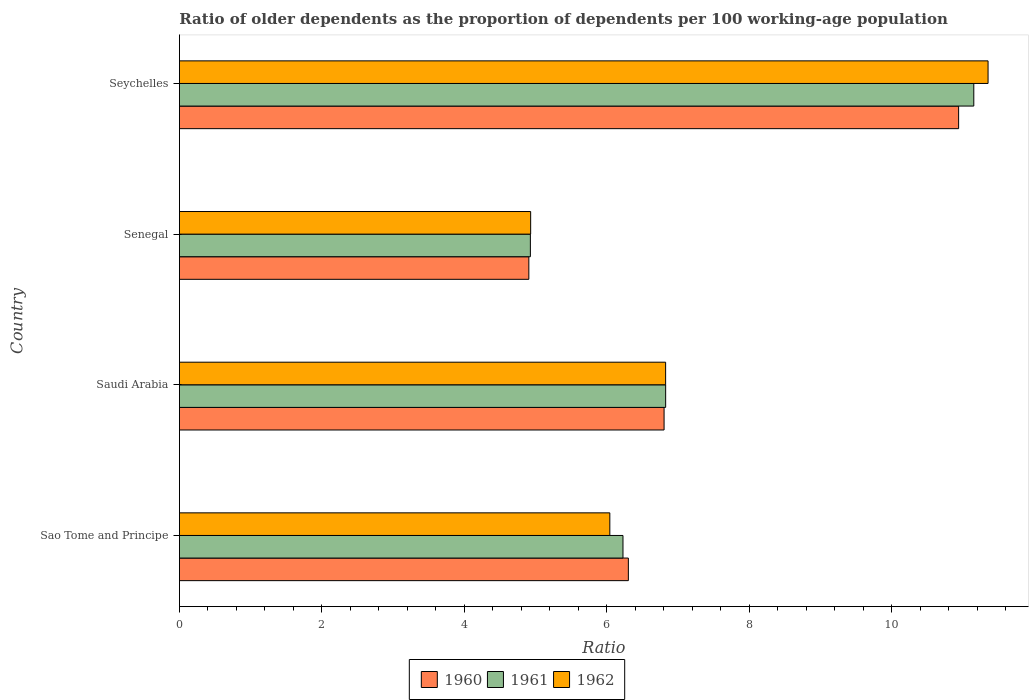How many different coloured bars are there?
Offer a terse response. 3. How many bars are there on the 2nd tick from the top?
Give a very brief answer. 3. What is the label of the 3rd group of bars from the top?
Your answer should be compact. Saudi Arabia. What is the age dependency ratio(old) in 1960 in Saudi Arabia?
Make the answer very short. 6.8. Across all countries, what is the maximum age dependency ratio(old) in 1962?
Keep it short and to the point. 11.35. Across all countries, what is the minimum age dependency ratio(old) in 1962?
Offer a terse response. 4.93. In which country was the age dependency ratio(old) in 1961 maximum?
Your answer should be very brief. Seychelles. In which country was the age dependency ratio(old) in 1962 minimum?
Offer a terse response. Senegal. What is the total age dependency ratio(old) in 1961 in the graph?
Give a very brief answer. 29.13. What is the difference between the age dependency ratio(old) in 1961 in Sao Tome and Principe and that in Saudi Arabia?
Provide a short and direct response. -0.6. What is the difference between the age dependency ratio(old) in 1962 in Saudi Arabia and the age dependency ratio(old) in 1960 in Senegal?
Ensure brevity in your answer.  1.92. What is the average age dependency ratio(old) in 1962 per country?
Your answer should be compact. 7.29. What is the difference between the age dependency ratio(old) in 1960 and age dependency ratio(old) in 1961 in Saudi Arabia?
Ensure brevity in your answer.  -0.02. What is the ratio of the age dependency ratio(old) in 1962 in Sao Tome and Principe to that in Saudi Arabia?
Your response must be concise. 0.89. Is the age dependency ratio(old) in 1960 in Saudi Arabia less than that in Seychelles?
Ensure brevity in your answer.  Yes. Is the difference between the age dependency ratio(old) in 1960 in Sao Tome and Principe and Seychelles greater than the difference between the age dependency ratio(old) in 1961 in Sao Tome and Principe and Seychelles?
Keep it short and to the point. Yes. What is the difference between the highest and the second highest age dependency ratio(old) in 1960?
Your response must be concise. 4.13. What is the difference between the highest and the lowest age dependency ratio(old) in 1962?
Your response must be concise. 6.42. Is the sum of the age dependency ratio(old) in 1960 in Sao Tome and Principe and Saudi Arabia greater than the maximum age dependency ratio(old) in 1961 across all countries?
Ensure brevity in your answer.  Yes. Is it the case that in every country, the sum of the age dependency ratio(old) in 1960 and age dependency ratio(old) in 1962 is greater than the age dependency ratio(old) in 1961?
Provide a succinct answer. Yes. Are all the bars in the graph horizontal?
Your response must be concise. Yes. How many countries are there in the graph?
Your response must be concise. 4. How many legend labels are there?
Ensure brevity in your answer.  3. What is the title of the graph?
Your response must be concise. Ratio of older dependents as the proportion of dependents per 100 working-age population. What is the label or title of the X-axis?
Your answer should be compact. Ratio. What is the label or title of the Y-axis?
Ensure brevity in your answer.  Country. What is the Ratio in 1960 in Sao Tome and Principe?
Offer a terse response. 6.3. What is the Ratio in 1961 in Sao Tome and Principe?
Offer a very short reply. 6.23. What is the Ratio of 1962 in Sao Tome and Principe?
Your answer should be very brief. 6.04. What is the Ratio of 1960 in Saudi Arabia?
Your answer should be compact. 6.8. What is the Ratio of 1961 in Saudi Arabia?
Your answer should be very brief. 6.83. What is the Ratio of 1962 in Saudi Arabia?
Your answer should be very brief. 6.83. What is the Ratio of 1960 in Senegal?
Your response must be concise. 4.91. What is the Ratio of 1961 in Senegal?
Provide a short and direct response. 4.93. What is the Ratio in 1962 in Senegal?
Provide a short and direct response. 4.93. What is the Ratio in 1960 in Seychelles?
Your answer should be compact. 10.94. What is the Ratio in 1961 in Seychelles?
Ensure brevity in your answer.  11.15. What is the Ratio of 1962 in Seychelles?
Your response must be concise. 11.35. Across all countries, what is the maximum Ratio of 1960?
Give a very brief answer. 10.94. Across all countries, what is the maximum Ratio in 1961?
Offer a terse response. 11.15. Across all countries, what is the maximum Ratio in 1962?
Your response must be concise. 11.35. Across all countries, what is the minimum Ratio of 1960?
Your answer should be very brief. 4.91. Across all countries, what is the minimum Ratio of 1961?
Your answer should be compact. 4.93. Across all countries, what is the minimum Ratio in 1962?
Offer a terse response. 4.93. What is the total Ratio of 1960 in the graph?
Offer a terse response. 28.95. What is the total Ratio in 1961 in the graph?
Offer a very short reply. 29.13. What is the total Ratio in 1962 in the graph?
Offer a very short reply. 29.15. What is the difference between the Ratio in 1960 in Sao Tome and Principe and that in Saudi Arabia?
Keep it short and to the point. -0.5. What is the difference between the Ratio of 1961 in Sao Tome and Principe and that in Saudi Arabia?
Offer a terse response. -0.6. What is the difference between the Ratio of 1962 in Sao Tome and Principe and that in Saudi Arabia?
Offer a terse response. -0.78. What is the difference between the Ratio in 1960 in Sao Tome and Principe and that in Senegal?
Make the answer very short. 1.4. What is the difference between the Ratio of 1961 in Sao Tome and Principe and that in Senegal?
Keep it short and to the point. 1.3. What is the difference between the Ratio of 1962 in Sao Tome and Principe and that in Senegal?
Your response must be concise. 1.11. What is the difference between the Ratio in 1960 in Sao Tome and Principe and that in Seychelles?
Your answer should be compact. -4.64. What is the difference between the Ratio of 1961 in Sao Tome and Principe and that in Seychelles?
Provide a short and direct response. -4.92. What is the difference between the Ratio in 1962 in Sao Tome and Principe and that in Seychelles?
Offer a very short reply. -5.31. What is the difference between the Ratio of 1960 in Saudi Arabia and that in Senegal?
Keep it short and to the point. 1.9. What is the difference between the Ratio of 1961 in Saudi Arabia and that in Senegal?
Your response must be concise. 1.9. What is the difference between the Ratio of 1962 in Saudi Arabia and that in Senegal?
Offer a terse response. 1.89. What is the difference between the Ratio in 1960 in Saudi Arabia and that in Seychelles?
Provide a succinct answer. -4.13. What is the difference between the Ratio in 1961 in Saudi Arabia and that in Seychelles?
Keep it short and to the point. -4.33. What is the difference between the Ratio in 1962 in Saudi Arabia and that in Seychelles?
Give a very brief answer. -4.53. What is the difference between the Ratio in 1960 in Senegal and that in Seychelles?
Provide a succinct answer. -6.03. What is the difference between the Ratio in 1961 in Senegal and that in Seychelles?
Provide a succinct answer. -6.22. What is the difference between the Ratio in 1962 in Senegal and that in Seychelles?
Your answer should be compact. -6.42. What is the difference between the Ratio of 1960 in Sao Tome and Principe and the Ratio of 1961 in Saudi Arabia?
Ensure brevity in your answer.  -0.52. What is the difference between the Ratio of 1960 in Sao Tome and Principe and the Ratio of 1962 in Saudi Arabia?
Your answer should be very brief. -0.52. What is the difference between the Ratio of 1961 in Sao Tome and Principe and the Ratio of 1962 in Saudi Arabia?
Ensure brevity in your answer.  -0.6. What is the difference between the Ratio in 1960 in Sao Tome and Principe and the Ratio in 1961 in Senegal?
Give a very brief answer. 1.38. What is the difference between the Ratio in 1960 in Sao Tome and Principe and the Ratio in 1962 in Senegal?
Make the answer very short. 1.37. What is the difference between the Ratio of 1961 in Sao Tome and Principe and the Ratio of 1962 in Senegal?
Make the answer very short. 1.3. What is the difference between the Ratio in 1960 in Sao Tome and Principe and the Ratio in 1961 in Seychelles?
Keep it short and to the point. -4.85. What is the difference between the Ratio in 1960 in Sao Tome and Principe and the Ratio in 1962 in Seychelles?
Keep it short and to the point. -5.05. What is the difference between the Ratio in 1961 in Sao Tome and Principe and the Ratio in 1962 in Seychelles?
Ensure brevity in your answer.  -5.12. What is the difference between the Ratio in 1960 in Saudi Arabia and the Ratio in 1961 in Senegal?
Ensure brevity in your answer.  1.88. What is the difference between the Ratio of 1960 in Saudi Arabia and the Ratio of 1962 in Senegal?
Your answer should be very brief. 1.87. What is the difference between the Ratio in 1961 in Saudi Arabia and the Ratio in 1962 in Senegal?
Provide a short and direct response. 1.9. What is the difference between the Ratio of 1960 in Saudi Arabia and the Ratio of 1961 in Seychelles?
Your answer should be very brief. -4.35. What is the difference between the Ratio in 1960 in Saudi Arabia and the Ratio in 1962 in Seychelles?
Make the answer very short. -4.55. What is the difference between the Ratio in 1961 in Saudi Arabia and the Ratio in 1962 in Seychelles?
Give a very brief answer. -4.53. What is the difference between the Ratio in 1960 in Senegal and the Ratio in 1961 in Seychelles?
Your answer should be very brief. -6.25. What is the difference between the Ratio in 1960 in Senegal and the Ratio in 1962 in Seychelles?
Give a very brief answer. -6.45. What is the difference between the Ratio of 1961 in Senegal and the Ratio of 1962 in Seychelles?
Offer a terse response. -6.42. What is the average Ratio of 1960 per country?
Make the answer very short. 7.24. What is the average Ratio in 1961 per country?
Ensure brevity in your answer.  7.28. What is the average Ratio of 1962 per country?
Offer a very short reply. 7.29. What is the difference between the Ratio in 1960 and Ratio in 1961 in Sao Tome and Principe?
Offer a terse response. 0.08. What is the difference between the Ratio of 1960 and Ratio of 1962 in Sao Tome and Principe?
Offer a very short reply. 0.26. What is the difference between the Ratio in 1961 and Ratio in 1962 in Sao Tome and Principe?
Make the answer very short. 0.18. What is the difference between the Ratio in 1960 and Ratio in 1961 in Saudi Arabia?
Your response must be concise. -0.02. What is the difference between the Ratio of 1960 and Ratio of 1962 in Saudi Arabia?
Offer a very short reply. -0.02. What is the difference between the Ratio of 1961 and Ratio of 1962 in Saudi Arabia?
Your answer should be compact. 0. What is the difference between the Ratio in 1960 and Ratio in 1961 in Senegal?
Offer a very short reply. -0.02. What is the difference between the Ratio of 1960 and Ratio of 1962 in Senegal?
Your answer should be very brief. -0.03. What is the difference between the Ratio in 1961 and Ratio in 1962 in Senegal?
Your answer should be compact. -0. What is the difference between the Ratio of 1960 and Ratio of 1961 in Seychelles?
Your answer should be very brief. -0.21. What is the difference between the Ratio in 1960 and Ratio in 1962 in Seychelles?
Provide a succinct answer. -0.41. What is the difference between the Ratio of 1961 and Ratio of 1962 in Seychelles?
Your response must be concise. -0.2. What is the ratio of the Ratio in 1960 in Sao Tome and Principe to that in Saudi Arabia?
Offer a terse response. 0.93. What is the ratio of the Ratio of 1961 in Sao Tome and Principe to that in Saudi Arabia?
Offer a terse response. 0.91. What is the ratio of the Ratio of 1962 in Sao Tome and Principe to that in Saudi Arabia?
Keep it short and to the point. 0.89. What is the ratio of the Ratio in 1960 in Sao Tome and Principe to that in Senegal?
Provide a short and direct response. 1.28. What is the ratio of the Ratio of 1961 in Sao Tome and Principe to that in Senegal?
Your response must be concise. 1.26. What is the ratio of the Ratio in 1962 in Sao Tome and Principe to that in Senegal?
Provide a short and direct response. 1.23. What is the ratio of the Ratio of 1960 in Sao Tome and Principe to that in Seychelles?
Make the answer very short. 0.58. What is the ratio of the Ratio of 1961 in Sao Tome and Principe to that in Seychelles?
Make the answer very short. 0.56. What is the ratio of the Ratio in 1962 in Sao Tome and Principe to that in Seychelles?
Your answer should be compact. 0.53. What is the ratio of the Ratio of 1960 in Saudi Arabia to that in Senegal?
Provide a short and direct response. 1.39. What is the ratio of the Ratio in 1961 in Saudi Arabia to that in Senegal?
Make the answer very short. 1.39. What is the ratio of the Ratio in 1962 in Saudi Arabia to that in Senegal?
Your response must be concise. 1.38. What is the ratio of the Ratio of 1960 in Saudi Arabia to that in Seychelles?
Your response must be concise. 0.62. What is the ratio of the Ratio in 1961 in Saudi Arabia to that in Seychelles?
Your response must be concise. 0.61. What is the ratio of the Ratio of 1962 in Saudi Arabia to that in Seychelles?
Your answer should be compact. 0.6. What is the ratio of the Ratio of 1960 in Senegal to that in Seychelles?
Offer a terse response. 0.45. What is the ratio of the Ratio of 1961 in Senegal to that in Seychelles?
Your response must be concise. 0.44. What is the ratio of the Ratio in 1962 in Senegal to that in Seychelles?
Provide a succinct answer. 0.43. What is the difference between the highest and the second highest Ratio in 1960?
Offer a terse response. 4.13. What is the difference between the highest and the second highest Ratio in 1961?
Make the answer very short. 4.33. What is the difference between the highest and the second highest Ratio of 1962?
Ensure brevity in your answer.  4.53. What is the difference between the highest and the lowest Ratio of 1960?
Keep it short and to the point. 6.03. What is the difference between the highest and the lowest Ratio in 1961?
Provide a succinct answer. 6.22. What is the difference between the highest and the lowest Ratio of 1962?
Ensure brevity in your answer.  6.42. 